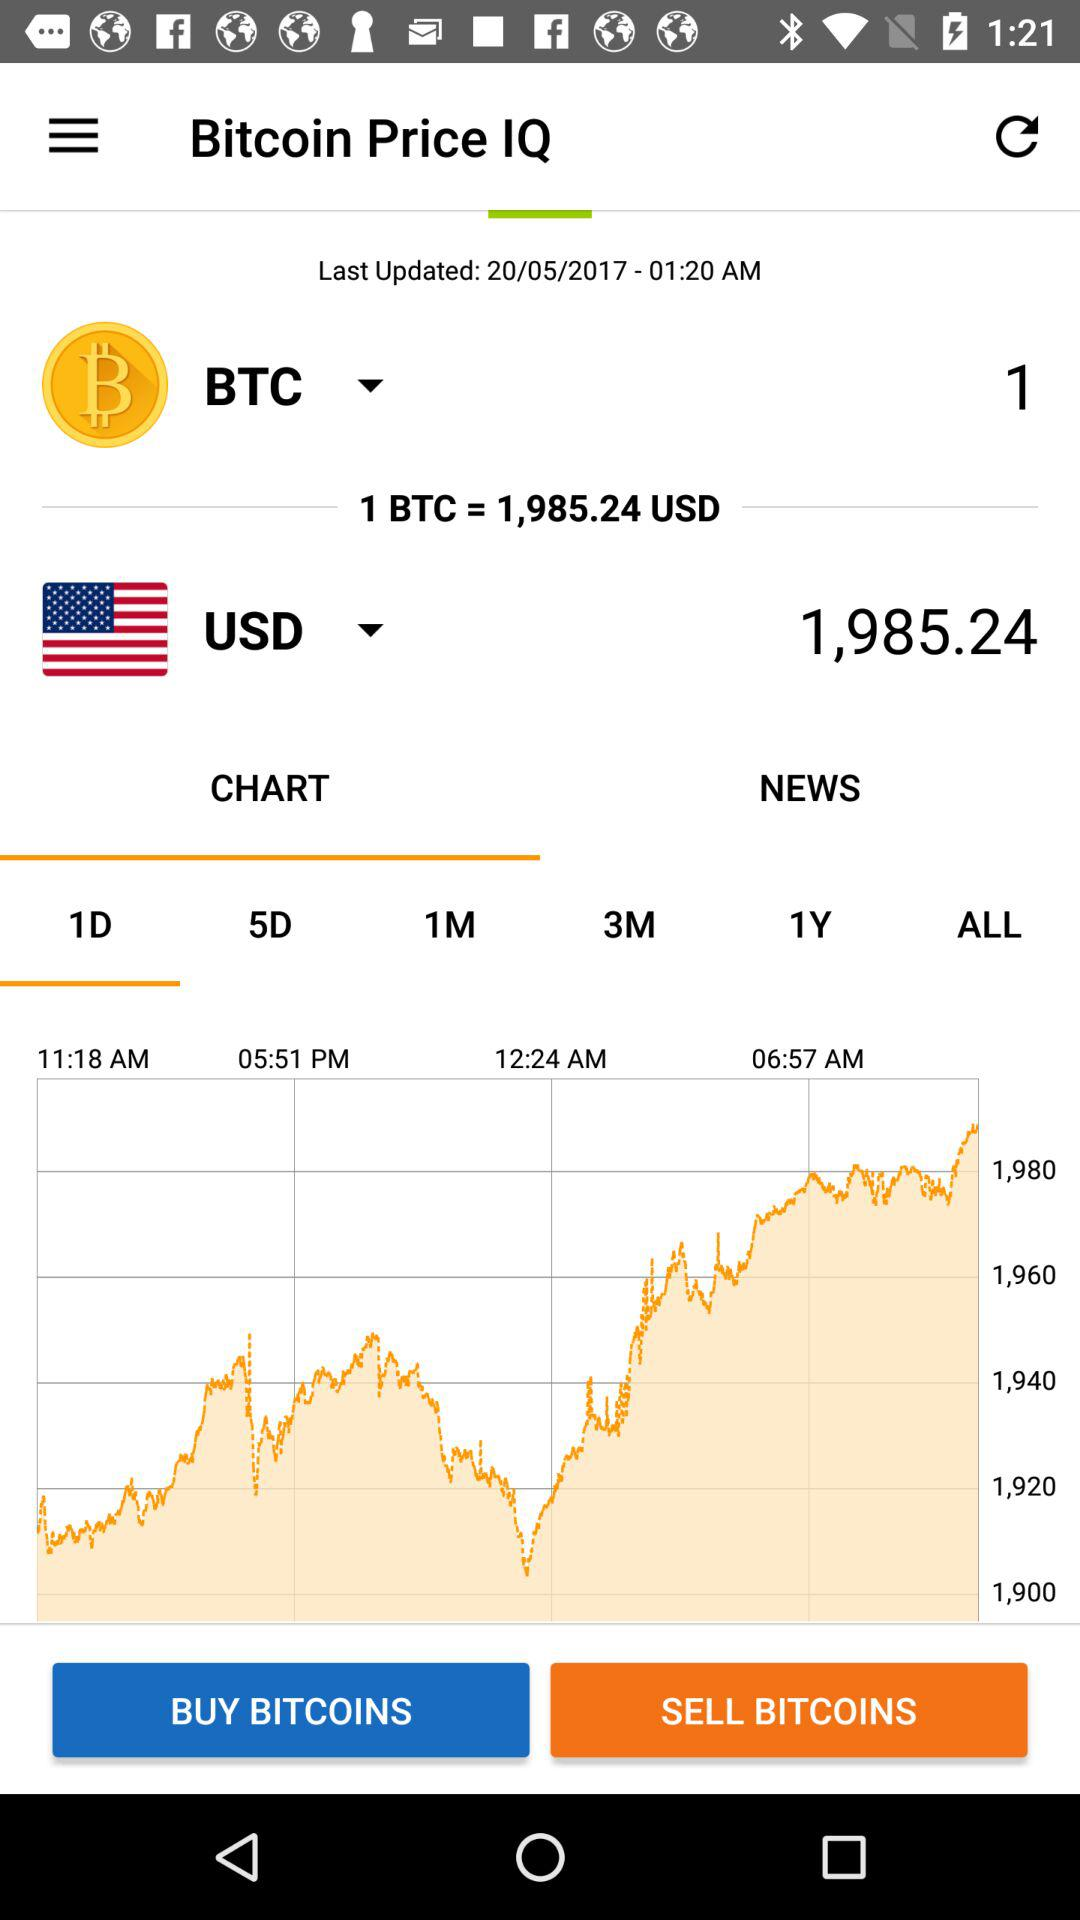What is the application name? The application name is "Bitcoin Price IQ". 